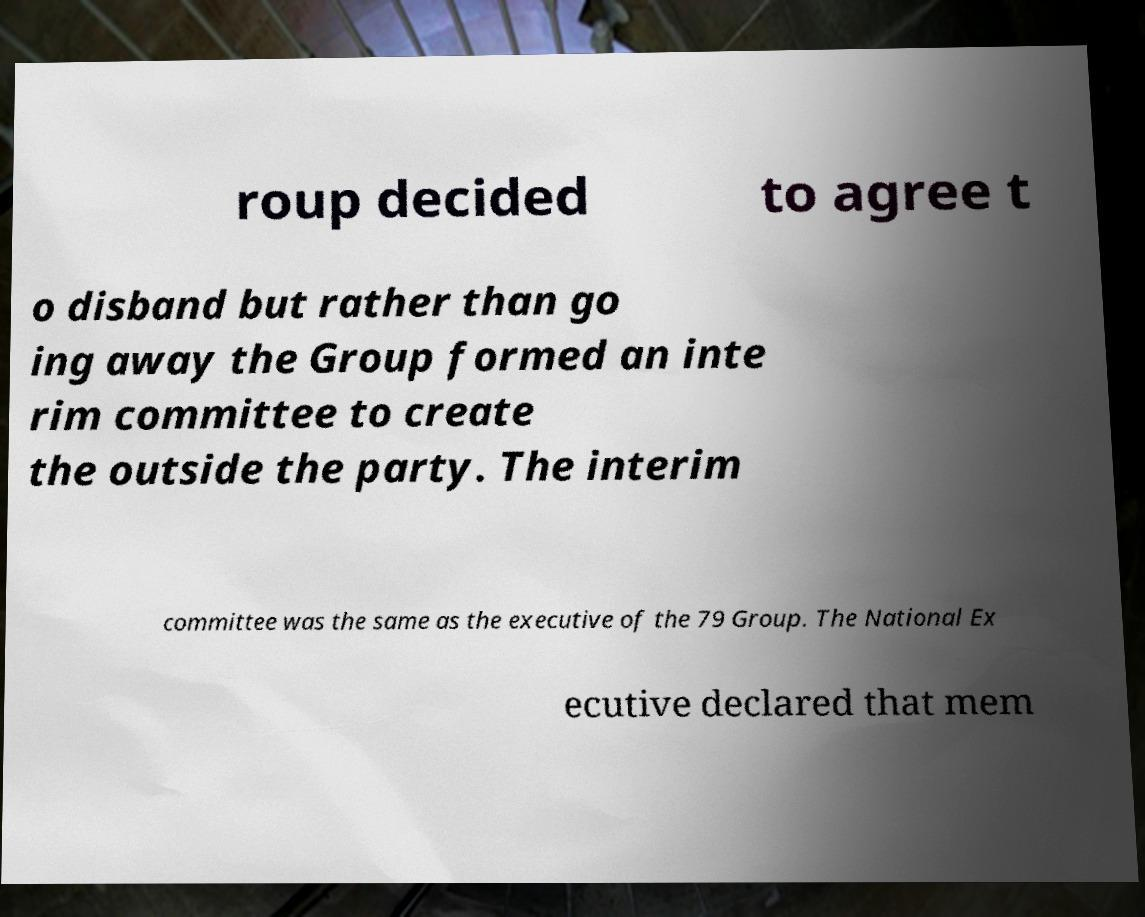Please read and relay the text visible in this image. What does it say? roup decided to agree t o disband but rather than go ing away the Group formed an inte rim committee to create the outside the party. The interim committee was the same as the executive of the 79 Group. The National Ex ecutive declared that mem 